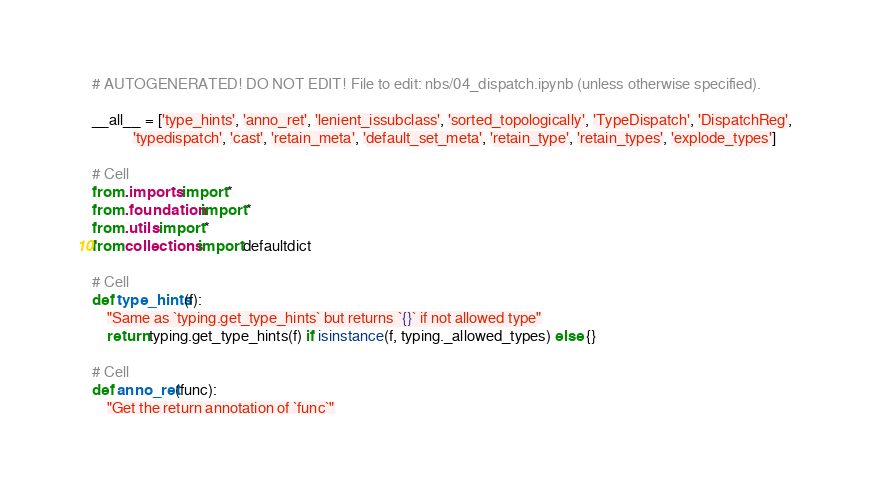<code> <loc_0><loc_0><loc_500><loc_500><_Python_># AUTOGENERATED! DO NOT EDIT! File to edit: nbs/04_dispatch.ipynb (unless otherwise specified).

__all__ = ['type_hints', 'anno_ret', 'lenient_issubclass', 'sorted_topologically', 'TypeDispatch', 'DispatchReg',
           'typedispatch', 'cast', 'retain_meta', 'default_set_meta', 'retain_type', 'retain_types', 'explode_types']

# Cell
from .imports import *
from .foundation import *
from .utils import *
from collections import defaultdict

# Cell
def type_hints(f):
    "Same as `typing.get_type_hints` but returns `{}` if not allowed type"
    return typing.get_type_hints(f) if isinstance(f, typing._allowed_types) else {}

# Cell
def anno_ret(func):
    "Get the return annotation of `func`"</code> 